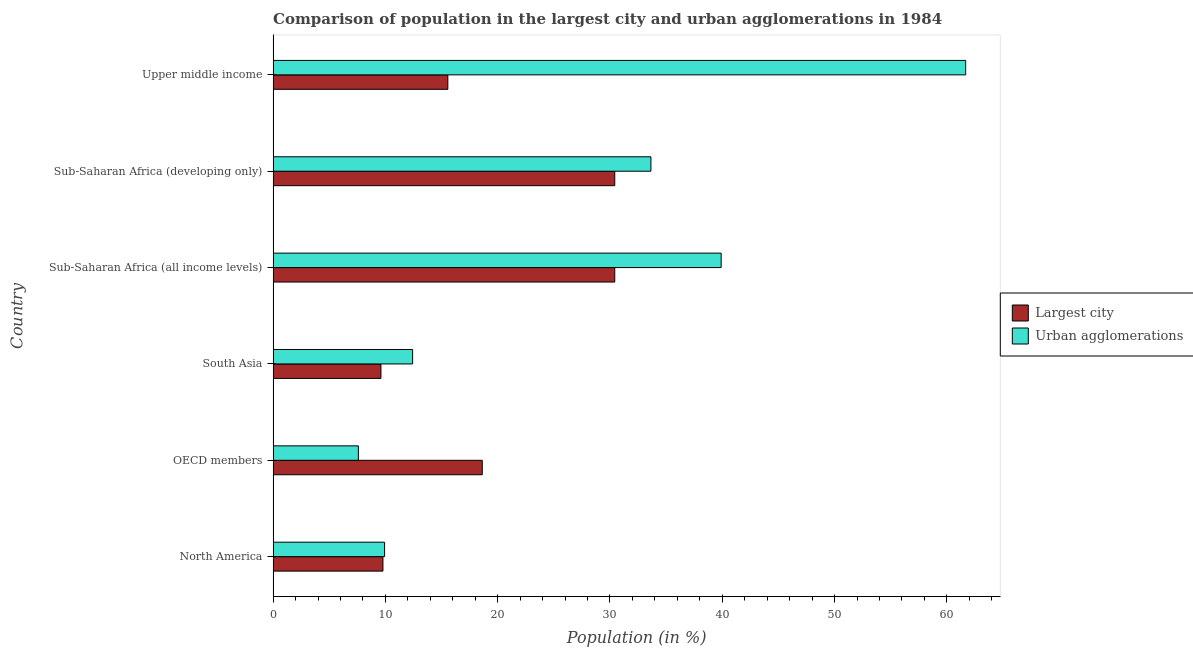How many different coloured bars are there?
Offer a terse response. 2. How many groups of bars are there?
Keep it short and to the point. 6. Are the number of bars on each tick of the Y-axis equal?
Provide a short and direct response. Yes. How many bars are there on the 5th tick from the bottom?
Make the answer very short. 2. What is the label of the 2nd group of bars from the top?
Offer a terse response. Sub-Saharan Africa (developing only). In how many cases, is the number of bars for a given country not equal to the number of legend labels?
Provide a short and direct response. 0. What is the population in urban agglomerations in Upper middle income?
Offer a terse response. 61.68. Across all countries, what is the maximum population in the largest city?
Your answer should be compact. 30.42. Across all countries, what is the minimum population in urban agglomerations?
Your response must be concise. 7.59. In which country was the population in the largest city maximum?
Give a very brief answer. Sub-Saharan Africa (all income levels). What is the total population in urban agglomerations in the graph?
Your answer should be very brief. 165.16. What is the difference between the population in the largest city in South Asia and that in Sub-Saharan Africa (developing only)?
Give a very brief answer. -20.82. What is the difference between the population in the largest city in South Asia and the population in urban agglomerations in North America?
Offer a very short reply. -0.32. What is the average population in urban agglomerations per country?
Your response must be concise. 27.53. What is the difference between the population in the largest city and population in urban agglomerations in Sub-Saharan Africa (all income levels)?
Provide a short and direct response. -9.48. What is the ratio of the population in urban agglomerations in South Asia to that in Upper middle income?
Give a very brief answer. 0.2. Is the population in urban agglomerations in Sub-Saharan Africa (developing only) less than that in Upper middle income?
Offer a very short reply. Yes. Is the difference between the population in the largest city in North America and Upper middle income greater than the difference between the population in urban agglomerations in North America and Upper middle income?
Offer a terse response. Yes. What is the difference between the highest and the second highest population in the largest city?
Provide a short and direct response. 0. What is the difference between the highest and the lowest population in the largest city?
Ensure brevity in your answer.  20.82. Is the sum of the population in urban agglomerations in Sub-Saharan Africa (all income levels) and Upper middle income greater than the maximum population in the largest city across all countries?
Your response must be concise. Yes. What does the 1st bar from the top in OECD members represents?
Ensure brevity in your answer.  Urban agglomerations. What does the 2nd bar from the bottom in Sub-Saharan Africa (developing only) represents?
Give a very brief answer. Urban agglomerations. How many bars are there?
Your answer should be very brief. 12. Are the values on the major ticks of X-axis written in scientific E-notation?
Your answer should be compact. No. Does the graph contain any zero values?
Provide a succinct answer. No. Does the graph contain grids?
Offer a very short reply. No. Where does the legend appear in the graph?
Provide a short and direct response. Center right. How are the legend labels stacked?
Ensure brevity in your answer.  Vertical. What is the title of the graph?
Offer a terse response. Comparison of population in the largest city and urban agglomerations in 1984. Does "Under-five" appear as one of the legend labels in the graph?
Ensure brevity in your answer.  No. What is the label or title of the X-axis?
Your answer should be very brief. Population (in %). What is the Population (in %) in Largest city in North America?
Your answer should be compact. 9.78. What is the Population (in %) in Urban agglomerations in North America?
Ensure brevity in your answer.  9.93. What is the Population (in %) of Largest city in OECD members?
Your answer should be very brief. 18.63. What is the Population (in %) in Urban agglomerations in OECD members?
Your response must be concise. 7.59. What is the Population (in %) of Largest city in South Asia?
Your response must be concise. 9.6. What is the Population (in %) of Urban agglomerations in South Asia?
Your response must be concise. 12.42. What is the Population (in %) of Largest city in Sub-Saharan Africa (all income levels)?
Offer a very short reply. 30.42. What is the Population (in %) of Urban agglomerations in Sub-Saharan Africa (all income levels)?
Offer a very short reply. 39.9. What is the Population (in %) in Largest city in Sub-Saharan Africa (developing only)?
Provide a short and direct response. 30.42. What is the Population (in %) in Urban agglomerations in Sub-Saharan Africa (developing only)?
Your answer should be very brief. 33.65. What is the Population (in %) of Largest city in Upper middle income?
Ensure brevity in your answer.  15.56. What is the Population (in %) in Urban agglomerations in Upper middle income?
Provide a succinct answer. 61.68. Across all countries, what is the maximum Population (in %) in Largest city?
Provide a succinct answer. 30.42. Across all countries, what is the maximum Population (in %) of Urban agglomerations?
Make the answer very short. 61.68. Across all countries, what is the minimum Population (in %) of Largest city?
Keep it short and to the point. 9.6. Across all countries, what is the minimum Population (in %) of Urban agglomerations?
Offer a terse response. 7.59. What is the total Population (in %) in Largest city in the graph?
Keep it short and to the point. 114.42. What is the total Population (in %) of Urban agglomerations in the graph?
Ensure brevity in your answer.  165.16. What is the difference between the Population (in %) in Largest city in North America and that in OECD members?
Ensure brevity in your answer.  -8.85. What is the difference between the Population (in %) of Urban agglomerations in North America and that in OECD members?
Offer a very short reply. 2.34. What is the difference between the Population (in %) in Largest city in North America and that in South Asia?
Offer a terse response. 0.18. What is the difference between the Population (in %) of Urban agglomerations in North America and that in South Asia?
Make the answer very short. -2.5. What is the difference between the Population (in %) in Largest city in North America and that in Sub-Saharan Africa (all income levels)?
Ensure brevity in your answer.  -20.65. What is the difference between the Population (in %) in Urban agglomerations in North America and that in Sub-Saharan Africa (all income levels)?
Your answer should be compact. -29.98. What is the difference between the Population (in %) in Largest city in North America and that in Sub-Saharan Africa (developing only)?
Give a very brief answer. -20.65. What is the difference between the Population (in %) in Urban agglomerations in North America and that in Sub-Saharan Africa (developing only)?
Give a very brief answer. -23.72. What is the difference between the Population (in %) in Largest city in North America and that in Upper middle income?
Provide a short and direct response. -5.78. What is the difference between the Population (in %) in Urban agglomerations in North America and that in Upper middle income?
Offer a terse response. -51.75. What is the difference between the Population (in %) in Largest city in OECD members and that in South Asia?
Your response must be concise. 9.02. What is the difference between the Population (in %) of Urban agglomerations in OECD members and that in South Asia?
Make the answer very short. -4.83. What is the difference between the Population (in %) of Largest city in OECD members and that in Sub-Saharan Africa (all income levels)?
Offer a very short reply. -11.8. What is the difference between the Population (in %) of Urban agglomerations in OECD members and that in Sub-Saharan Africa (all income levels)?
Keep it short and to the point. -32.31. What is the difference between the Population (in %) in Largest city in OECD members and that in Sub-Saharan Africa (developing only)?
Keep it short and to the point. -11.8. What is the difference between the Population (in %) in Urban agglomerations in OECD members and that in Sub-Saharan Africa (developing only)?
Your answer should be compact. -26.05. What is the difference between the Population (in %) of Largest city in OECD members and that in Upper middle income?
Make the answer very short. 3.07. What is the difference between the Population (in %) in Urban agglomerations in OECD members and that in Upper middle income?
Offer a very short reply. -54.09. What is the difference between the Population (in %) of Largest city in South Asia and that in Sub-Saharan Africa (all income levels)?
Provide a succinct answer. -20.82. What is the difference between the Population (in %) in Urban agglomerations in South Asia and that in Sub-Saharan Africa (all income levels)?
Your response must be concise. -27.48. What is the difference between the Population (in %) in Largest city in South Asia and that in Sub-Saharan Africa (developing only)?
Ensure brevity in your answer.  -20.82. What is the difference between the Population (in %) of Urban agglomerations in South Asia and that in Sub-Saharan Africa (developing only)?
Your answer should be compact. -21.22. What is the difference between the Population (in %) of Largest city in South Asia and that in Upper middle income?
Ensure brevity in your answer.  -5.96. What is the difference between the Population (in %) in Urban agglomerations in South Asia and that in Upper middle income?
Your response must be concise. -49.25. What is the difference between the Population (in %) in Urban agglomerations in Sub-Saharan Africa (all income levels) and that in Sub-Saharan Africa (developing only)?
Provide a succinct answer. 6.26. What is the difference between the Population (in %) in Largest city in Sub-Saharan Africa (all income levels) and that in Upper middle income?
Give a very brief answer. 14.87. What is the difference between the Population (in %) in Urban agglomerations in Sub-Saharan Africa (all income levels) and that in Upper middle income?
Give a very brief answer. -21.77. What is the difference between the Population (in %) of Largest city in Sub-Saharan Africa (developing only) and that in Upper middle income?
Your answer should be compact. 14.87. What is the difference between the Population (in %) in Urban agglomerations in Sub-Saharan Africa (developing only) and that in Upper middle income?
Provide a short and direct response. -28.03. What is the difference between the Population (in %) of Largest city in North America and the Population (in %) of Urban agglomerations in OECD members?
Provide a succinct answer. 2.19. What is the difference between the Population (in %) in Largest city in North America and the Population (in %) in Urban agglomerations in South Asia?
Offer a very short reply. -2.64. What is the difference between the Population (in %) of Largest city in North America and the Population (in %) of Urban agglomerations in Sub-Saharan Africa (all income levels)?
Make the answer very short. -30.12. What is the difference between the Population (in %) of Largest city in North America and the Population (in %) of Urban agglomerations in Sub-Saharan Africa (developing only)?
Provide a succinct answer. -23.87. What is the difference between the Population (in %) in Largest city in North America and the Population (in %) in Urban agglomerations in Upper middle income?
Your answer should be compact. -51.9. What is the difference between the Population (in %) of Largest city in OECD members and the Population (in %) of Urban agglomerations in South Asia?
Provide a short and direct response. 6.2. What is the difference between the Population (in %) in Largest city in OECD members and the Population (in %) in Urban agglomerations in Sub-Saharan Africa (all income levels)?
Offer a terse response. -21.28. What is the difference between the Population (in %) of Largest city in OECD members and the Population (in %) of Urban agglomerations in Sub-Saharan Africa (developing only)?
Offer a very short reply. -15.02. What is the difference between the Population (in %) in Largest city in OECD members and the Population (in %) in Urban agglomerations in Upper middle income?
Your answer should be very brief. -43.05. What is the difference between the Population (in %) of Largest city in South Asia and the Population (in %) of Urban agglomerations in Sub-Saharan Africa (all income levels)?
Ensure brevity in your answer.  -30.3. What is the difference between the Population (in %) of Largest city in South Asia and the Population (in %) of Urban agglomerations in Sub-Saharan Africa (developing only)?
Make the answer very short. -24.04. What is the difference between the Population (in %) in Largest city in South Asia and the Population (in %) in Urban agglomerations in Upper middle income?
Ensure brevity in your answer.  -52.07. What is the difference between the Population (in %) in Largest city in Sub-Saharan Africa (all income levels) and the Population (in %) in Urban agglomerations in Sub-Saharan Africa (developing only)?
Ensure brevity in your answer.  -3.22. What is the difference between the Population (in %) of Largest city in Sub-Saharan Africa (all income levels) and the Population (in %) of Urban agglomerations in Upper middle income?
Make the answer very short. -31.25. What is the difference between the Population (in %) in Largest city in Sub-Saharan Africa (developing only) and the Population (in %) in Urban agglomerations in Upper middle income?
Provide a succinct answer. -31.25. What is the average Population (in %) of Largest city per country?
Keep it short and to the point. 19.07. What is the average Population (in %) of Urban agglomerations per country?
Provide a short and direct response. 27.53. What is the difference between the Population (in %) in Largest city and Population (in %) in Urban agglomerations in North America?
Your response must be concise. -0.15. What is the difference between the Population (in %) of Largest city and Population (in %) of Urban agglomerations in OECD members?
Offer a terse response. 11.03. What is the difference between the Population (in %) in Largest city and Population (in %) in Urban agglomerations in South Asia?
Your answer should be compact. -2.82. What is the difference between the Population (in %) of Largest city and Population (in %) of Urban agglomerations in Sub-Saharan Africa (all income levels)?
Offer a very short reply. -9.48. What is the difference between the Population (in %) of Largest city and Population (in %) of Urban agglomerations in Sub-Saharan Africa (developing only)?
Provide a short and direct response. -3.22. What is the difference between the Population (in %) of Largest city and Population (in %) of Urban agglomerations in Upper middle income?
Ensure brevity in your answer.  -46.12. What is the ratio of the Population (in %) of Largest city in North America to that in OECD members?
Your answer should be very brief. 0.53. What is the ratio of the Population (in %) in Urban agglomerations in North America to that in OECD members?
Keep it short and to the point. 1.31. What is the ratio of the Population (in %) in Largest city in North America to that in South Asia?
Your response must be concise. 1.02. What is the ratio of the Population (in %) of Urban agglomerations in North America to that in South Asia?
Make the answer very short. 0.8. What is the ratio of the Population (in %) in Largest city in North America to that in Sub-Saharan Africa (all income levels)?
Your answer should be very brief. 0.32. What is the ratio of the Population (in %) of Urban agglomerations in North America to that in Sub-Saharan Africa (all income levels)?
Provide a short and direct response. 0.25. What is the ratio of the Population (in %) of Largest city in North America to that in Sub-Saharan Africa (developing only)?
Offer a terse response. 0.32. What is the ratio of the Population (in %) in Urban agglomerations in North America to that in Sub-Saharan Africa (developing only)?
Keep it short and to the point. 0.29. What is the ratio of the Population (in %) in Largest city in North America to that in Upper middle income?
Keep it short and to the point. 0.63. What is the ratio of the Population (in %) of Urban agglomerations in North America to that in Upper middle income?
Make the answer very short. 0.16. What is the ratio of the Population (in %) in Largest city in OECD members to that in South Asia?
Offer a very short reply. 1.94. What is the ratio of the Population (in %) of Urban agglomerations in OECD members to that in South Asia?
Keep it short and to the point. 0.61. What is the ratio of the Population (in %) in Largest city in OECD members to that in Sub-Saharan Africa (all income levels)?
Your response must be concise. 0.61. What is the ratio of the Population (in %) in Urban agglomerations in OECD members to that in Sub-Saharan Africa (all income levels)?
Your response must be concise. 0.19. What is the ratio of the Population (in %) of Largest city in OECD members to that in Sub-Saharan Africa (developing only)?
Ensure brevity in your answer.  0.61. What is the ratio of the Population (in %) of Urban agglomerations in OECD members to that in Sub-Saharan Africa (developing only)?
Offer a terse response. 0.23. What is the ratio of the Population (in %) in Largest city in OECD members to that in Upper middle income?
Your answer should be very brief. 1.2. What is the ratio of the Population (in %) of Urban agglomerations in OECD members to that in Upper middle income?
Offer a very short reply. 0.12. What is the ratio of the Population (in %) in Largest city in South Asia to that in Sub-Saharan Africa (all income levels)?
Your answer should be compact. 0.32. What is the ratio of the Population (in %) in Urban agglomerations in South Asia to that in Sub-Saharan Africa (all income levels)?
Provide a short and direct response. 0.31. What is the ratio of the Population (in %) in Largest city in South Asia to that in Sub-Saharan Africa (developing only)?
Offer a very short reply. 0.32. What is the ratio of the Population (in %) of Urban agglomerations in South Asia to that in Sub-Saharan Africa (developing only)?
Keep it short and to the point. 0.37. What is the ratio of the Population (in %) of Largest city in South Asia to that in Upper middle income?
Your answer should be compact. 0.62. What is the ratio of the Population (in %) of Urban agglomerations in South Asia to that in Upper middle income?
Offer a terse response. 0.2. What is the ratio of the Population (in %) of Largest city in Sub-Saharan Africa (all income levels) to that in Sub-Saharan Africa (developing only)?
Your response must be concise. 1. What is the ratio of the Population (in %) of Urban agglomerations in Sub-Saharan Africa (all income levels) to that in Sub-Saharan Africa (developing only)?
Give a very brief answer. 1.19. What is the ratio of the Population (in %) in Largest city in Sub-Saharan Africa (all income levels) to that in Upper middle income?
Offer a terse response. 1.96. What is the ratio of the Population (in %) in Urban agglomerations in Sub-Saharan Africa (all income levels) to that in Upper middle income?
Your answer should be compact. 0.65. What is the ratio of the Population (in %) of Largest city in Sub-Saharan Africa (developing only) to that in Upper middle income?
Your answer should be very brief. 1.96. What is the ratio of the Population (in %) in Urban agglomerations in Sub-Saharan Africa (developing only) to that in Upper middle income?
Make the answer very short. 0.55. What is the difference between the highest and the second highest Population (in %) in Largest city?
Offer a very short reply. 0. What is the difference between the highest and the second highest Population (in %) of Urban agglomerations?
Your answer should be compact. 21.77. What is the difference between the highest and the lowest Population (in %) in Largest city?
Offer a very short reply. 20.82. What is the difference between the highest and the lowest Population (in %) of Urban agglomerations?
Offer a terse response. 54.09. 